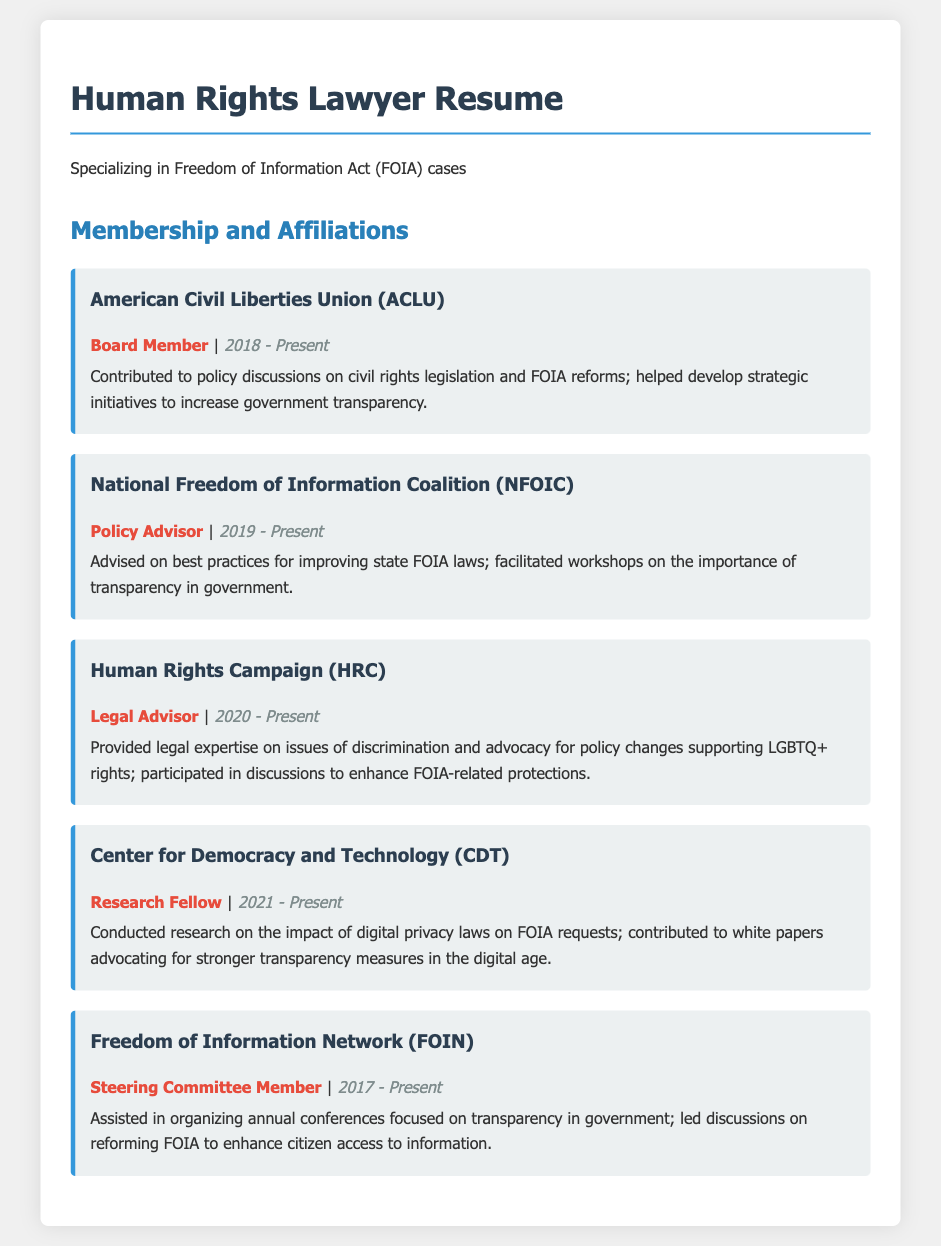What is the role of the individual at the ACLU? The individual holds the position of Board Member, as stated in the membership section for the ACLU.
Answer: Board Member When did the individual start serving as a Policy Advisor for the NFOIC? The start date for the role is indicated as 2019 in the document.
Answer: 2019 Which organization does the individual work with to enhance protections related to FOIA? The organization mentioned for enhancing FOIA protections is the Human Rights Campaign.
Answer: Human Rights Campaign What position does the individual hold in the Freedom of Information Network? The position held in the Freedom of Information Network is Steering Committee Member.
Answer: Steering Committee Member How long has the individual been a Research Fellow at the Center for Democracy and Technology? The duration is specified as starting in 2021 and continues to the present, indicating it has been at least 2 years.
Answer: 2 years Which organization is associated with organizing conferences on transparency in government? The organization associated with this activity is the Freedom of Information Network.
Answer: Freedom of Information Network What type of initiatives has the individual helped develop at the ACLU? The individual contributed to strategic initiatives focused on increasing government transparency at the ACLU.
Answer: Government transparency What is one contribution made by the individual to the NFOIC? The contribution mentioned is advising on best practices for improving state FOIA laws.
Answer: Advising on best practices Who does the individual advise on issues related to discrimination? The individual acts as a Legal Advisor to the Human Rights Campaign on discrimination issues.
Answer: Human Rights Campaign 